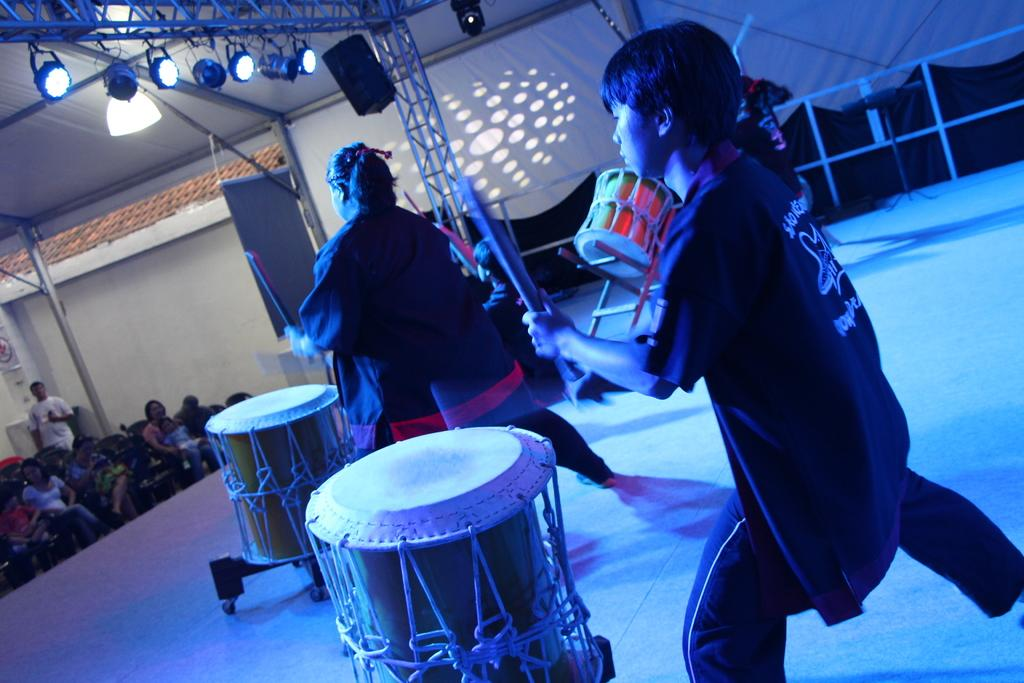What is happening on the stage in the image? There are three people on a stage, and they are playing a snare drum with drum sticks. What are the people in the audience doing? The people sitting on chairs and watching the stage are observing the performance. Can you see a lake in the background of the image? There is no lake visible in the image. Is anyone using a gun in the image? There is no gun present in the image. 